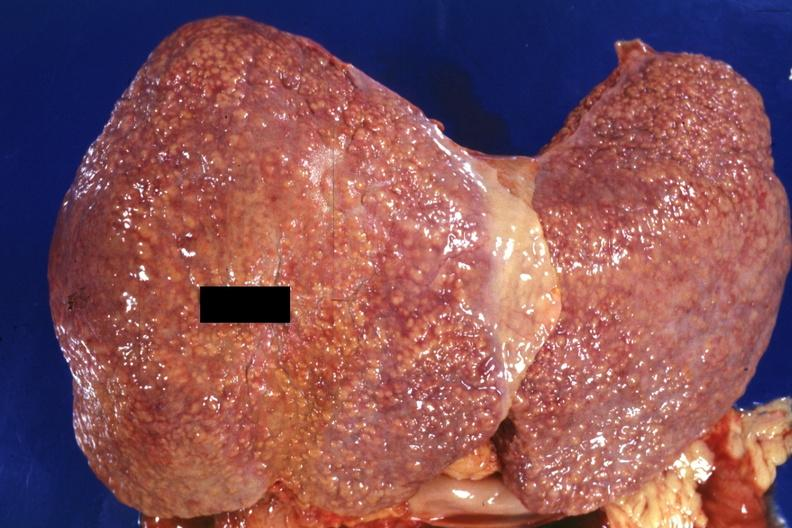what is present?
Answer the question using a single word or phrase. Hepatobiliary 